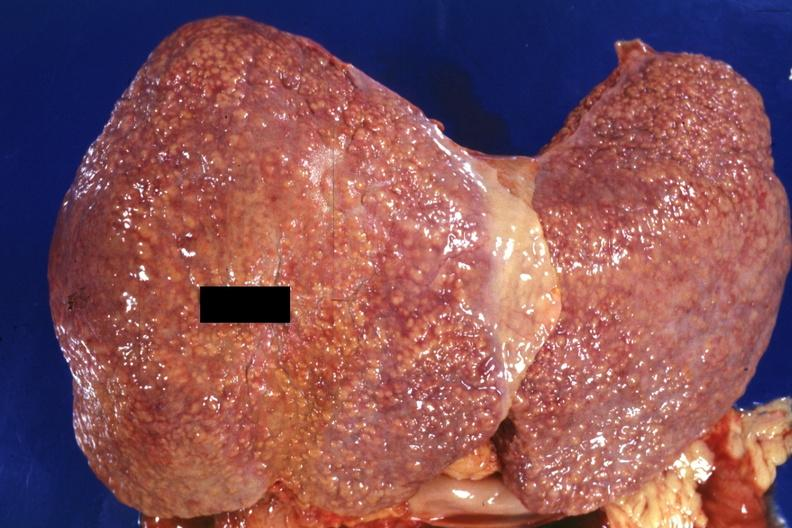what is present?
Answer the question using a single word or phrase. Hepatobiliary 